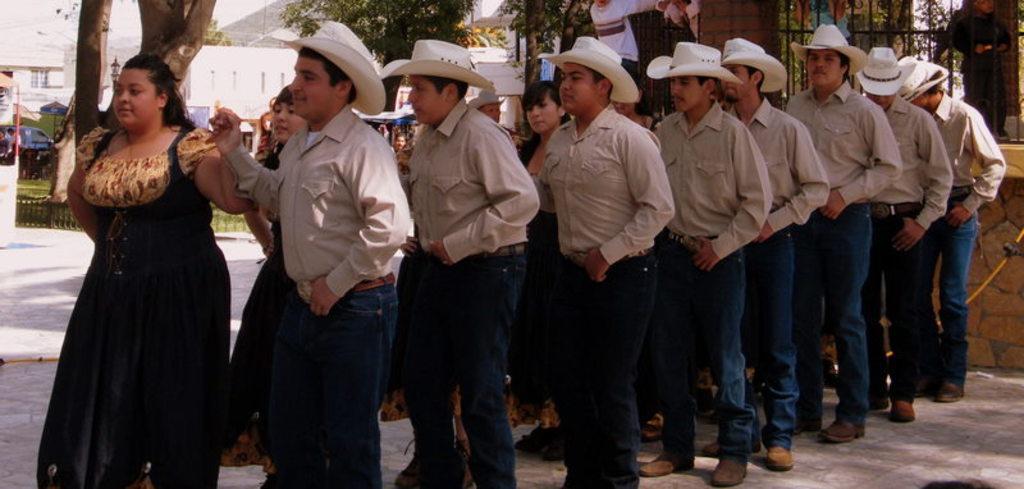In one or two sentences, can you explain what this image depicts? In this image there are a group of people who are wearing hats, and it seems that they are dancing. And in the background there are some trees, poles, wires, buildings, vehicles and some people, railing, wall and at the bottom there is a walkway. 